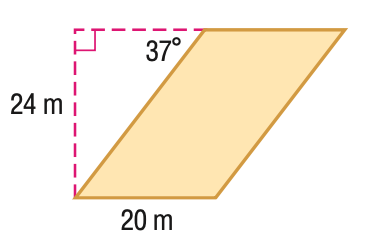Answer the mathemtical geometry problem and directly provide the correct option letter.
Question: Find the area of the parallelogram. Round to the nearest tenth if necessary.
Choices: A: 420 B: 480 C: 764.4 D: 797.6 B 